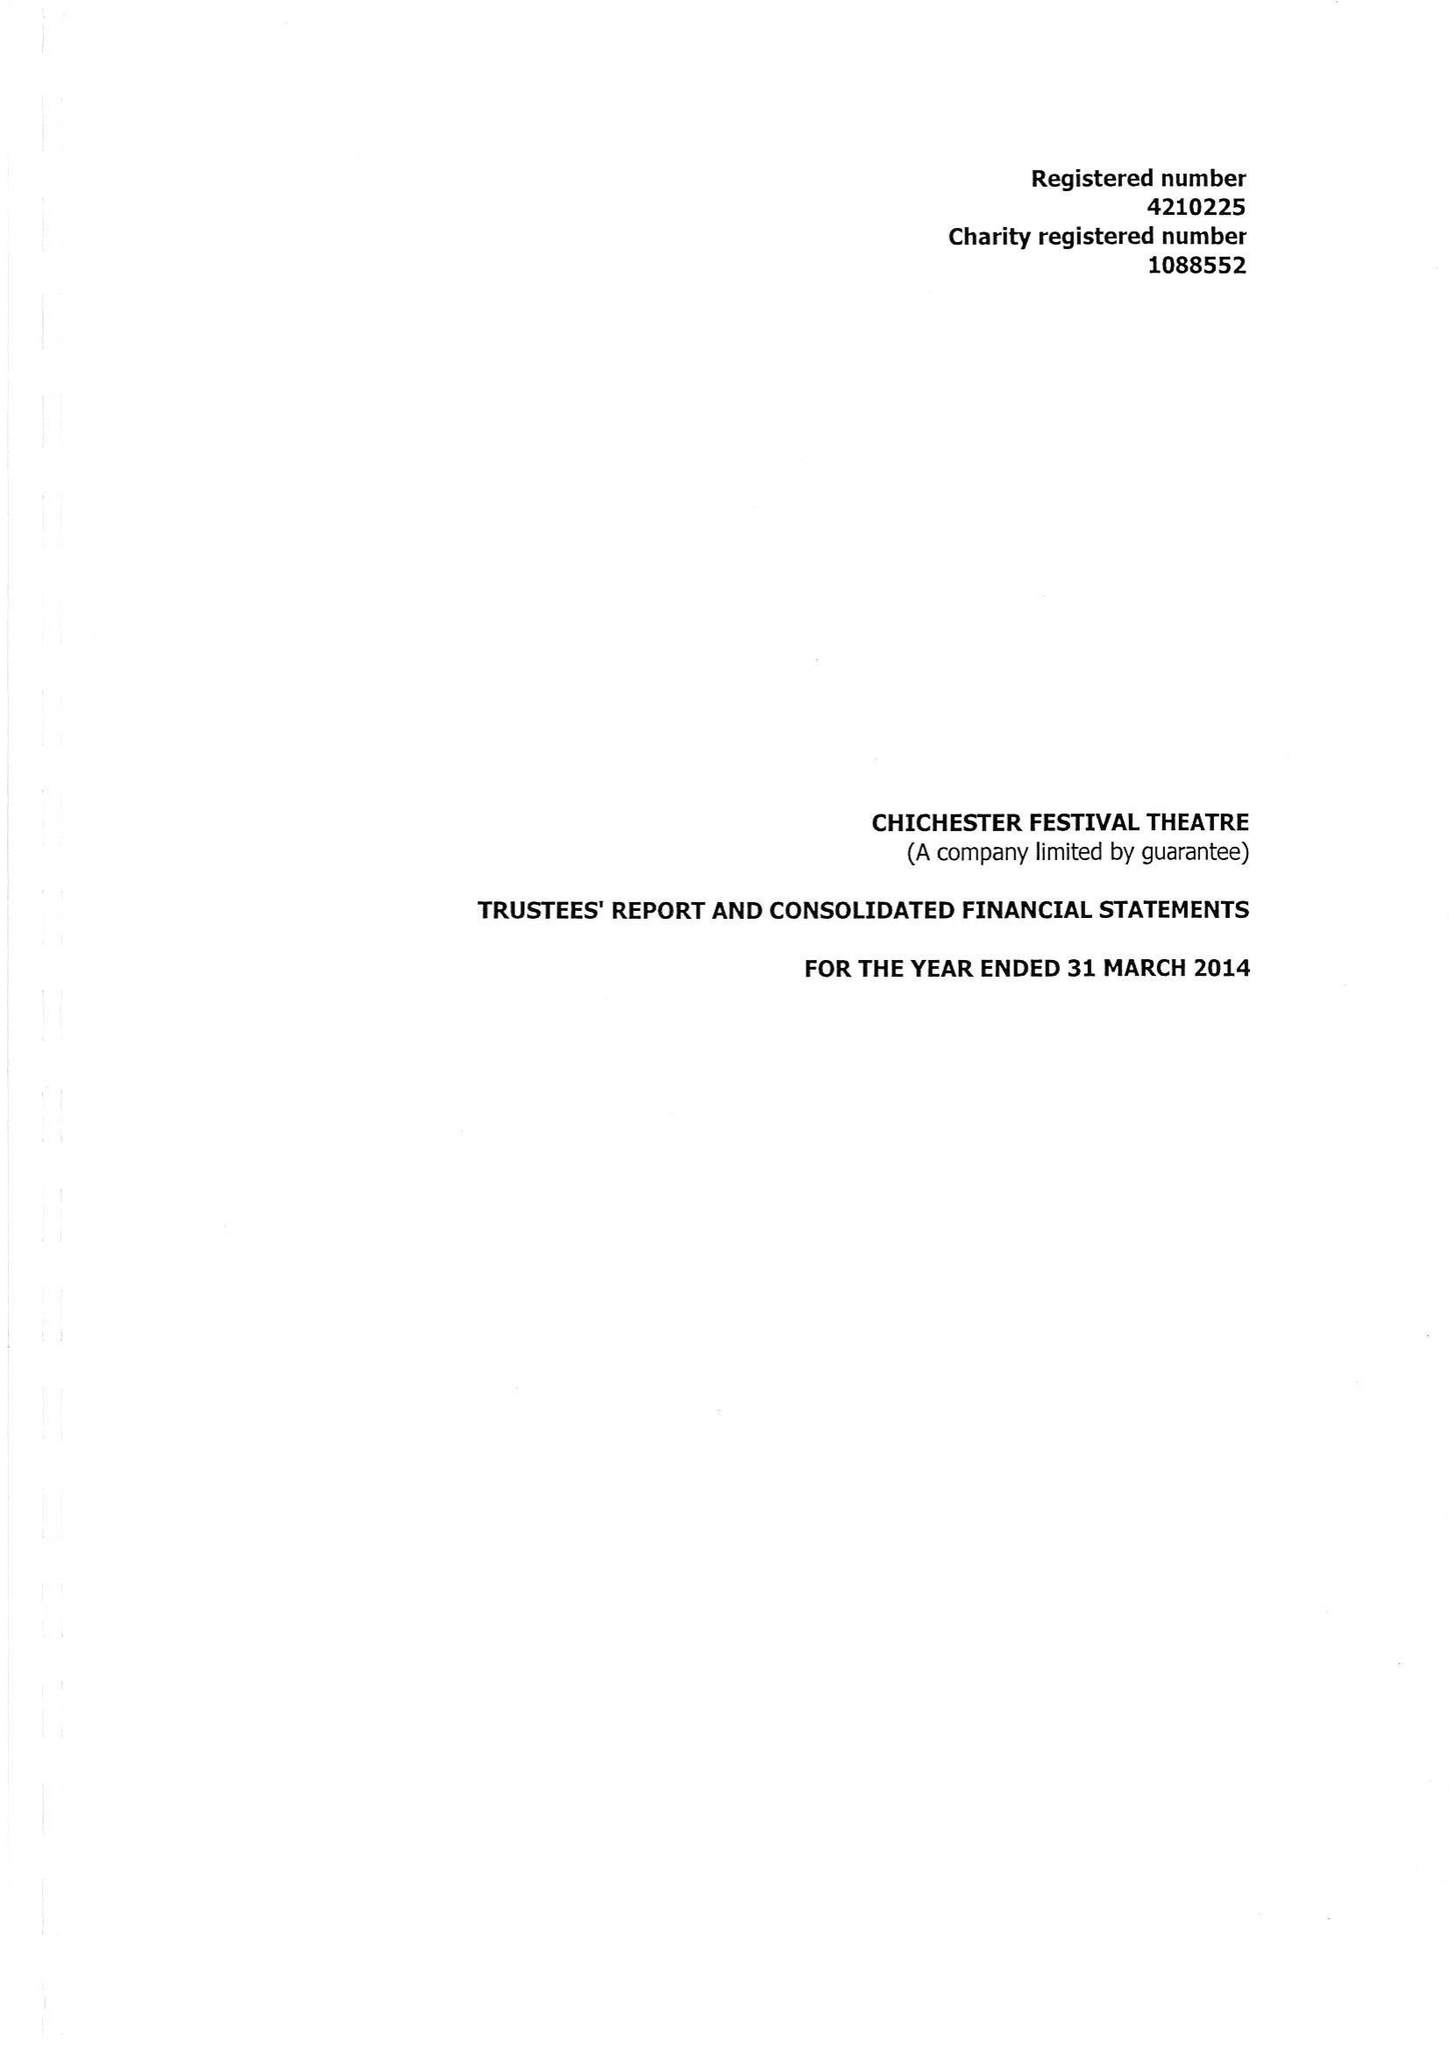What is the value for the income_annually_in_british_pounds?
Answer the question using a single word or phrase. 20874400.00 